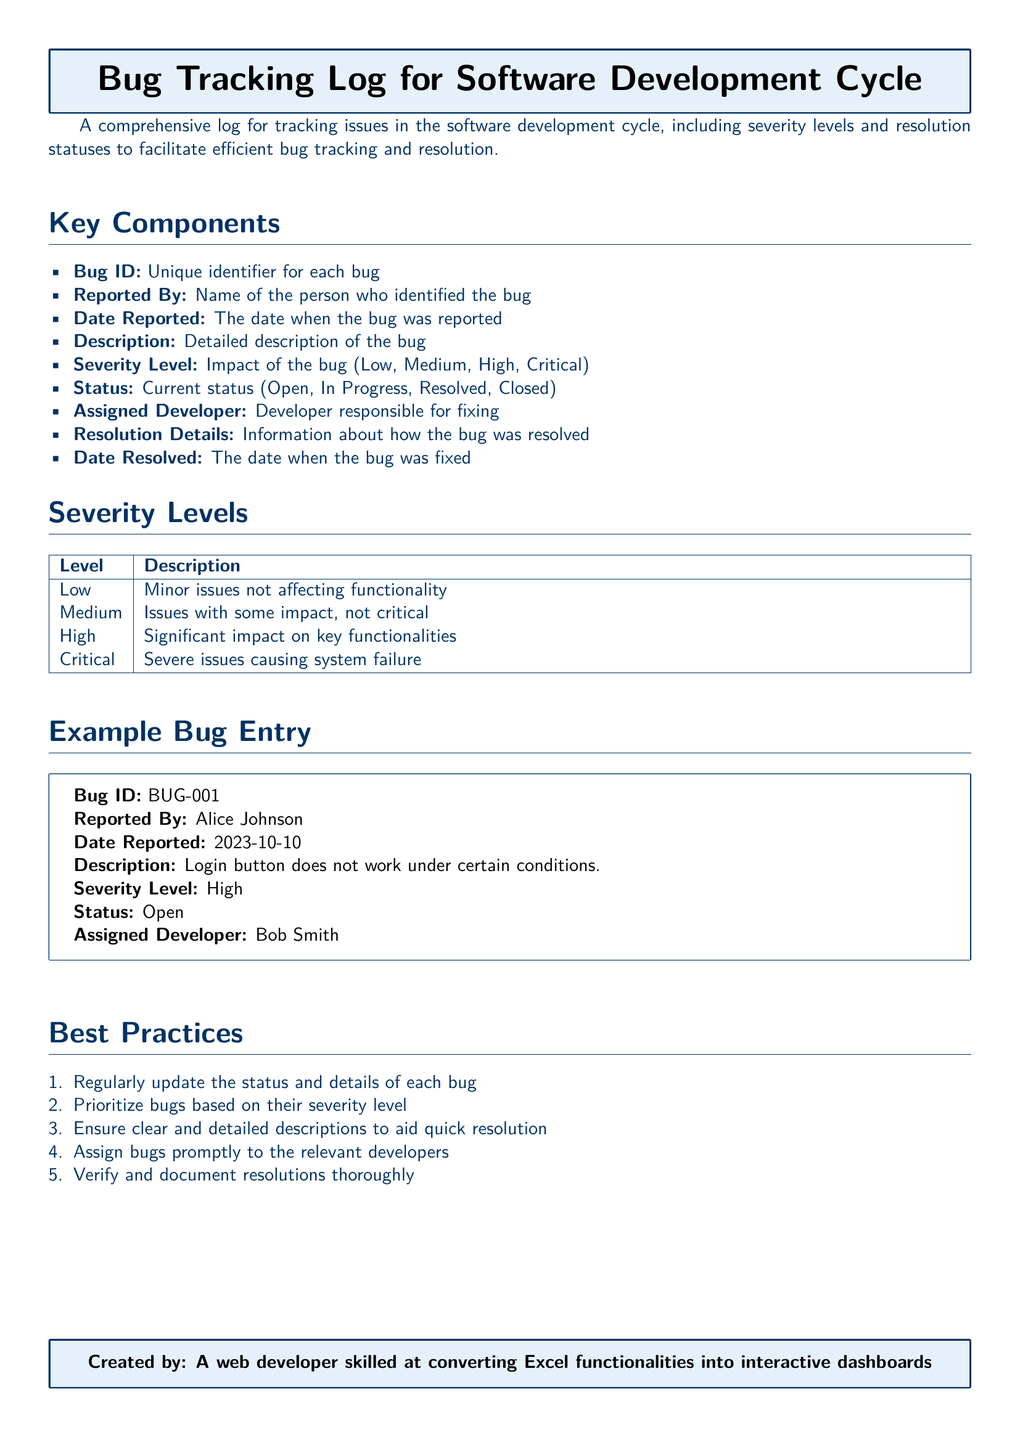What is the title of the document? The title is stated at the top of the document, indicating its purpose related to bug tracking in the software development cycle.
Answer: Bug Tracking Log for Software Development Cycle What is the severity level of the example bug entry? The severity level is mentioned in the details of the example bug entry, indicating its impact.
Answer: High Who reported the bug in the example entry? The name of the person who identified the bug is listed in the example bug entry section.
Answer: Alice Johnson What is the status of the example bug? The current status of the bug is included in the example bug entry.
Answer: Open How many severity levels are defined in the document? The document lists a specific number of severity levels in the severity levels section.
Answer: Four What should be regularly updated according to best practices? The best practices section provides guidelines on what information should be consistently reviewed.
Answer: Status and details of each bug What is the date reported for the example bug? The date when the bug was reported is clearly stated in the details of the example entry.
Answer: 2023-10-10 Who is responsible for fixing the example bug? The document specifies the person assigned to resolve the bug in the example entry.
Answer: Bob Smith What is the purpose of the document? The introduction section describes the main goal of creating this log.
Answer: Facilitate efficient bug tracking and resolution 